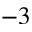Convert formula to latex. <formula><loc_0><loc_0><loc_500><loc_500>^ { - 3 }</formula> 